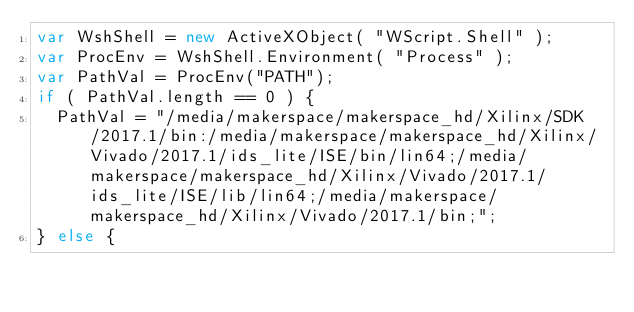<code> <loc_0><loc_0><loc_500><loc_500><_JavaScript_>var WshShell = new ActiveXObject( "WScript.Shell" );
var ProcEnv = WshShell.Environment( "Process" );
var PathVal = ProcEnv("PATH");
if ( PathVal.length == 0 ) {
  PathVal = "/media/makerspace/makerspace_hd/Xilinx/SDK/2017.1/bin:/media/makerspace/makerspace_hd/Xilinx/Vivado/2017.1/ids_lite/ISE/bin/lin64;/media/makerspace/makerspace_hd/Xilinx/Vivado/2017.1/ids_lite/ISE/lib/lin64;/media/makerspace/makerspace_hd/Xilinx/Vivado/2017.1/bin;";
} else {</code> 